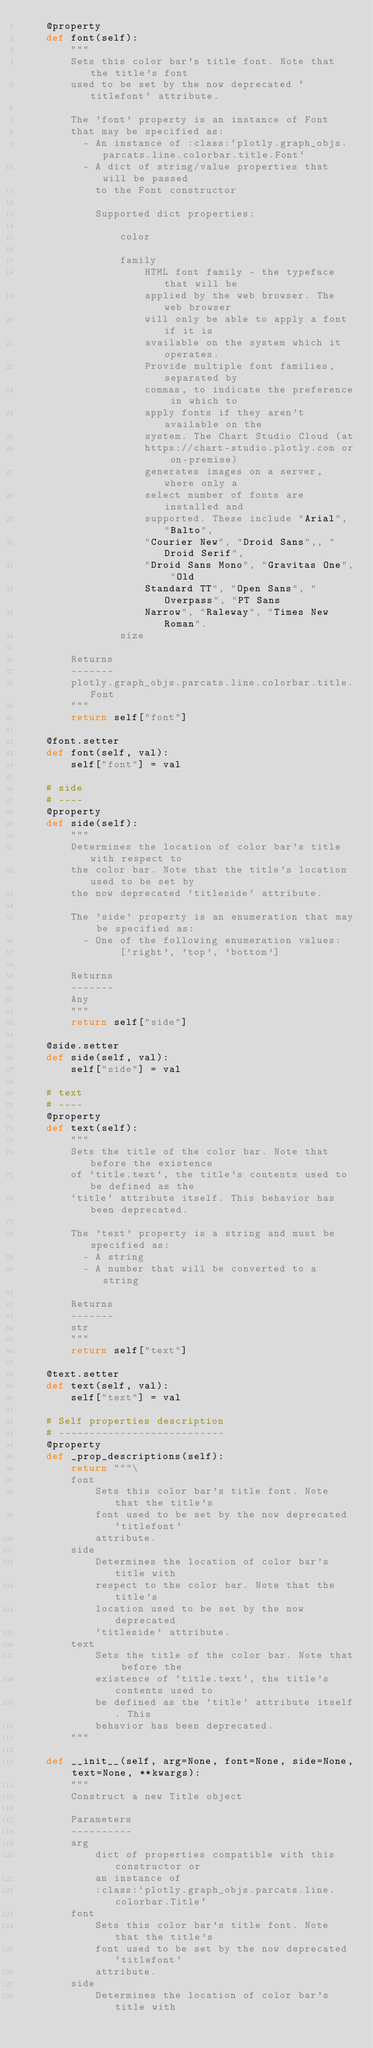Convert code to text. <code><loc_0><loc_0><loc_500><loc_500><_Python_>    @property
    def font(self):
        """
        Sets this color bar's title font. Note that the title's font
        used to be set by the now deprecated `titlefont` attribute.
    
        The 'font' property is an instance of Font
        that may be specified as:
          - An instance of :class:`plotly.graph_objs.parcats.line.colorbar.title.Font`
          - A dict of string/value properties that will be passed
            to the Font constructor
    
            Supported dict properties:
                
                color
    
                family
                    HTML font family - the typeface that will be
                    applied by the web browser. The web browser
                    will only be able to apply a font if it is
                    available on the system which it operates.
                    Provide multiple font families, separated by
                    commas, to indicate the preference in which to
                    apply fonts if they aren't available on the
                    system. The Chart Studio Cloud (at
                    https://chart-studio.plotly.com or on-premise)
                    generates images on a server, where only a
                    select number of fonts are installed and
                    supported. These include "Arial", "Balto",
                    "Courier New", "Droid Sans",, "Droid Serif",
                    "Droid Sans Mono", "Gravitas One", "Old
                    Standard TT", "Open Sans", "Overpass", "PT Sans
                    Narrow", "Raleway", "Times New Roman".
                size

        Returns
        -------
        plotly.graph_objs.parcats.line.colorbar.title.Font
        """
        return self["font"]

    @font.setter
    def font(self, val):
        self["font"] = val

    # side
    # ----
    @property
    def side(self):
        """
        Determines the location of color bar's title with respect to
        the color bar. Note that the title's location used to be set by
        the now deprecated `titleside` attribute.
    
        The 'side' property is an enumeration that may be specified as:
          - One of the following enumeration values:
                ['right', 'top', 'bottom']

        Returns
        -------
        Any
        """
        return self["side"]

    @side.setter
    def side(self, val):
        self["side"] = val

    # text
    # ----
    @property
    def text(self):
        """
        Sets the title of the color bar. Note that before the existence
        of `title.text`, the title's contents used to be defined as the
        `title` attribute itself. This behavior has been deprecated.
    
        The 'text' property is a string and must be specified as:
          - A string
          - A number that will be converted to a string

        Returns
        -------
        str
        """
        return self["text"]

    @text.setter
    def text(self, val):
        self["text"] = val

    # Self properties description
    # ---------------------------
    @property
    def _prop_descriptions(self):
        return """\
        font
            Sets this color bar's title font. Note that the title's
            font used to be set by the now deprecated `titlefont`
            attribute.
        side
            Determines the location of color bar's title with
            respect to the color bar. Note that the title's
            location used to be set by the now deprecated
            `titleside` attribute.
        text
            Sets the title of the color bar. Note that before the
            existence of `title.text`, the title's contents used to
            be defined as the `title` attribute itself. This
            behavior has been deprecated.
        """

    def __init__(self, arg=None, font=None, side=None, text=None, **kwargs):
        """
        Construct a new Title object
        
        Parameters
        ----------
        arg
            dict of properties compatible with this constructor or
            an instance of
            :class:`plotly.graph_objs.parcats.line.colorbar.Title`
        font
            Sets this color bar's title font. Note that the title's
            font used to be set by the now deprecated `titlefont`
            attribute.
        side
            Determines the location of color bar's title with</code> 